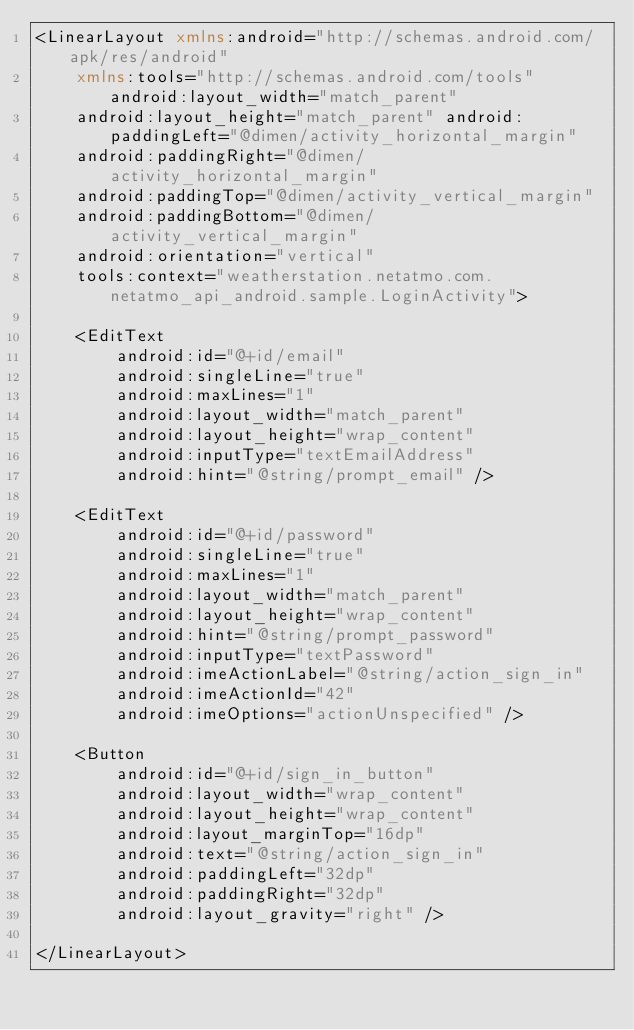Convert code to text. <code><loc_0><loc_0><loc_500><loc_500><_XML_><LinearLayout xmlns:android="http://schemas.android.com/apk/res/android"
    xmlns:tools="http://schemas.android.com/tools" android:layout_width="match_parent"
    android:layout_height="match_parent" android:paddingLeft="@dimen/activity_horizontal_margin"
    android:paddingRight="@dimen/activity_horizontal_margin"
    android:paddingTop="@dimen/activity_vertical_margin"
    android:paddingBottom="@dimen/activity_vertical_margin"
    android:orientation="vertical"
    tools:context="weatherstation.netatmo.com.netatmo_api_android.sample.LoginActivity">

    <EditText
        android:id="@+id/email"
        android:singleLine="true"
        android:maxLines="1"
        android:layout_width="match_parent"
        android:layout_height="wrap_content"
        android:inputType="textEmailAddress"
        android:hint="@string/prompt_email" />

    <EditText
        android:id="@+id/password"
        android:singleLine="true"
        android:maxLines="1"
        android:layout_width="match_parent"
        android:layout_height="wrap_content"
        android:hint="@string/prompt_password"
        android:inputType="textPassword"
        android:imeActionLabel="@string/action_sign_in"
        android:imeActionId="42"
        android:imeOptions="actionUnspecified" />

    <Button
        android:id="@+id/sign_in_button"
        android:layout_width="wrap_content"
        android:layout_height="wrap_content"
        android:layout_marginTop="16dp"
        android:text="@string/action_sign_in"
        android:paddingLeft="32dp"
        android:paddingRight="32dp"
        android:layout_gravity="right" />

</LinearLayout>
</code> 